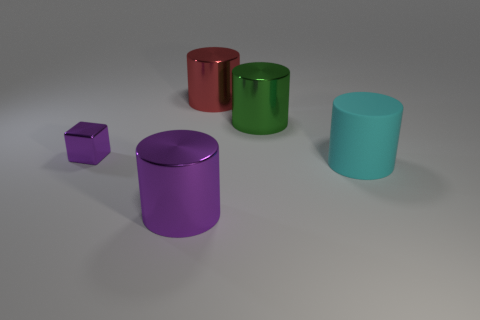Add 1 cyan cylinders. How many objects exist? 6 Subtract all cubes. How many objects are left? 4 Subtract 0 purple spheres. How many objects are left? 5 Subtract all large cyan metal objects. Subtract all green things. How many objects are left? 4 Add 4 big red metallic cylinders. How many big red metallic cylinders are left? 5 Add 4 purple metallic cubes. How many purple metallic cubes exist? 5 